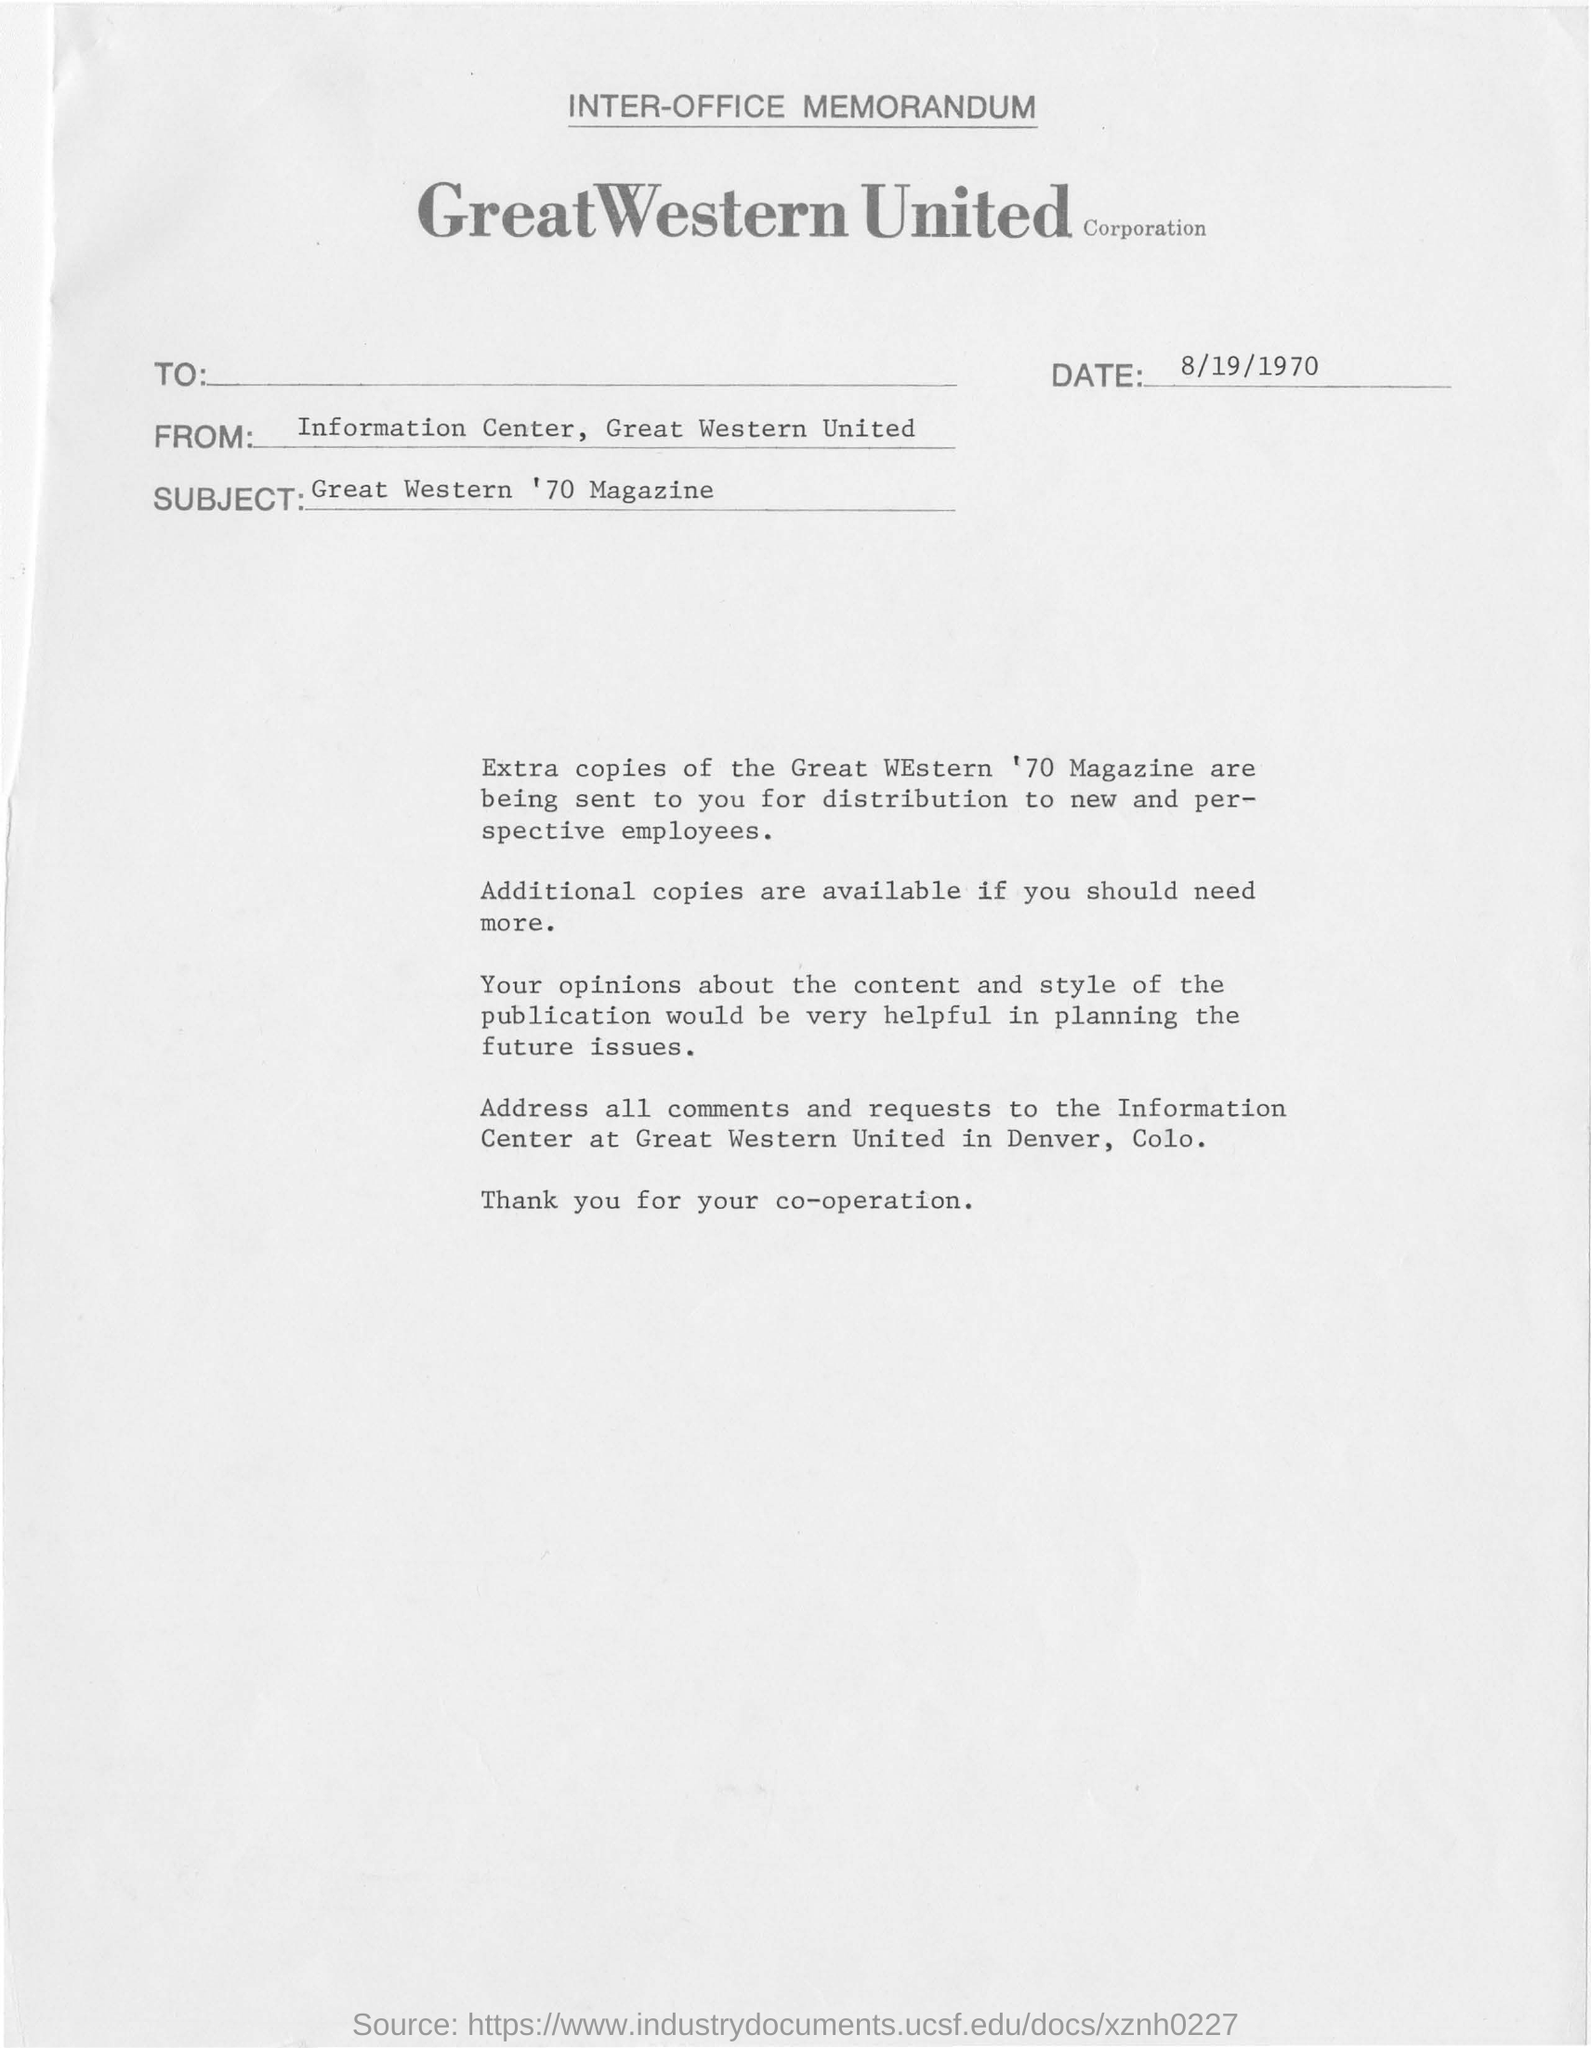Draw attention to some important aspects in this diagram. The memorandum in question bears the date August 19, 1970. The subject of the memorandum is the Great Western '70 Magazine. The memorandum is from the Information Center of Great Western United. 